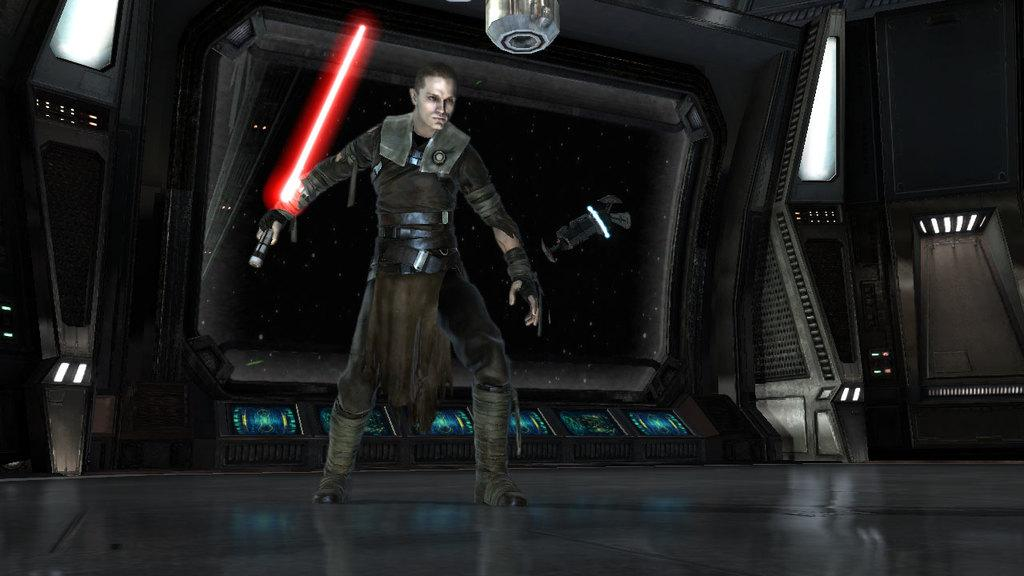What type of image is being described? The image is animated. Can you describe the person in the image? There is a person standing in the image, and they are holding a lightsaber. Where does the scene take place? The setting is inside a space ship. What language is the person speaking in the image? There is no dialogue or speech present in the image, so it is not possible to determine the language being spoken. 